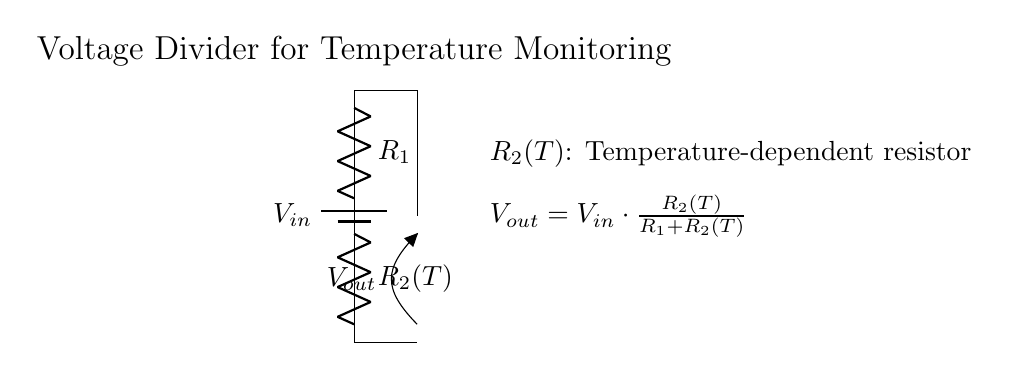what is the input voltage of this circuit? The input voltage is denoted as V in the circuit, which typically represents the source voltage connected to the voltage divider.
Answer: V in what type of resistor is R2 in this circuit? R2 is labeled as R2(T), indicating that it is a temperature-dependent resistor, which changes its resistance based on the temperature.
Answer: Temperature-dependent resistor how is the output voltage (V out) calculated? The output voltage V out is calculated using the formula V out = V in * (R2(T) / (R1 + R2(T))). This shows that V out is proportional to the resistance of R2 and affected by R1.
Answer: V out = V in * (R2(T) / (R1 + R2(T))) what will happen to the output voltage if the temperature increases? When the temperature increases, R2(T) decreases its resistance, resulting in a lower V out according to the voltage divider formula. This shows how the circuit is designed to react to temperature changes.
Answer: V out decreases what is the purpose of this voltage divider circuit? The purpose of this circuit is to monitor temperature by converting the change in resistance of the temperature-dependent resistor R2 into a measurable output voltage V out.
Answer: To monitor temperature how does changing R1 affect the output voltage? Changing R1 will affect the voltage divider ratio, thereby altering V out. An increase in R1 will decrease V out for a constant R2(T) and V in, while a decrease in R1 will increase V out.
Answer: It alters V out 